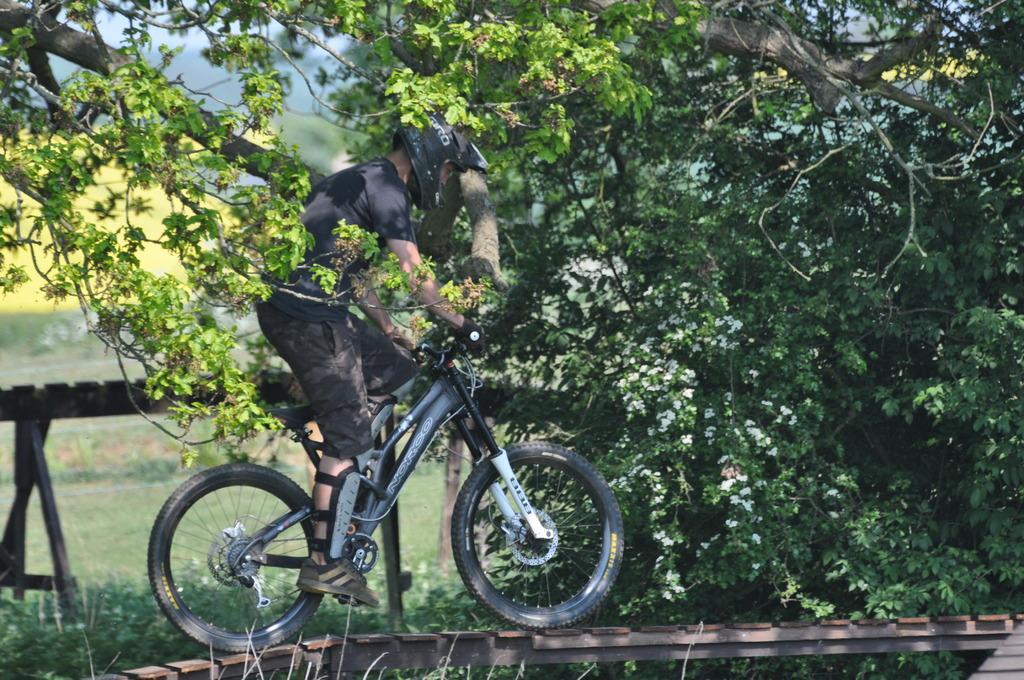In one or two sentences, can you explain what this image depicts? In the picture I can see a man riding a bicycle on the wooden walkway. He is wearing a black color T-shirt and trouser. In the background, I can see the trees. 